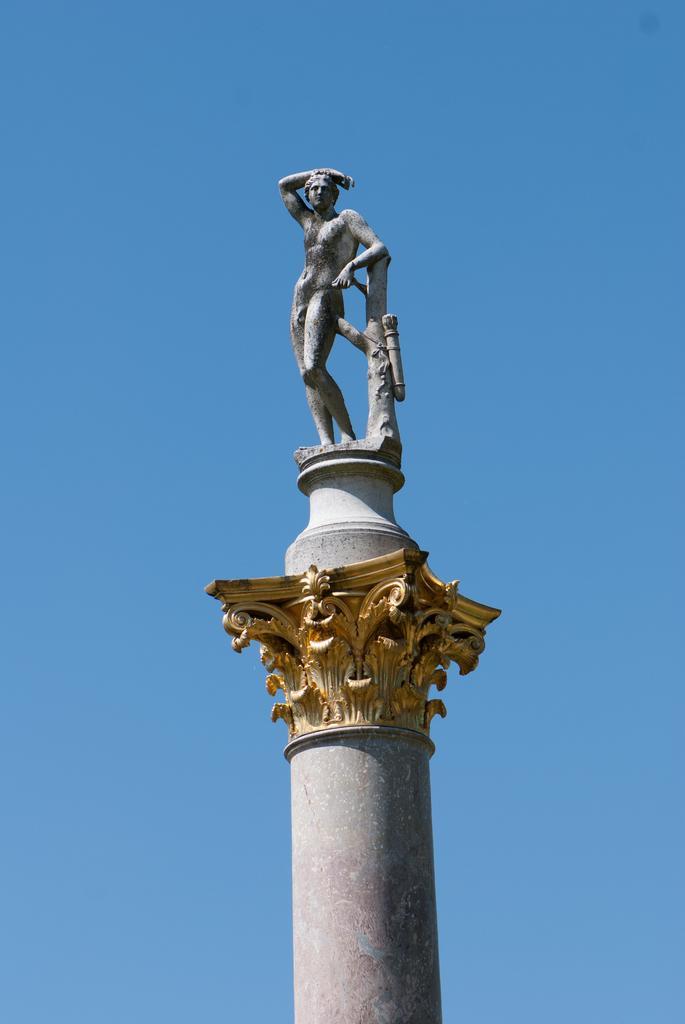Could you give a brief overview of what you see in this image? In this picture I can see in the middle there is a statue, at the top there is the sky. 